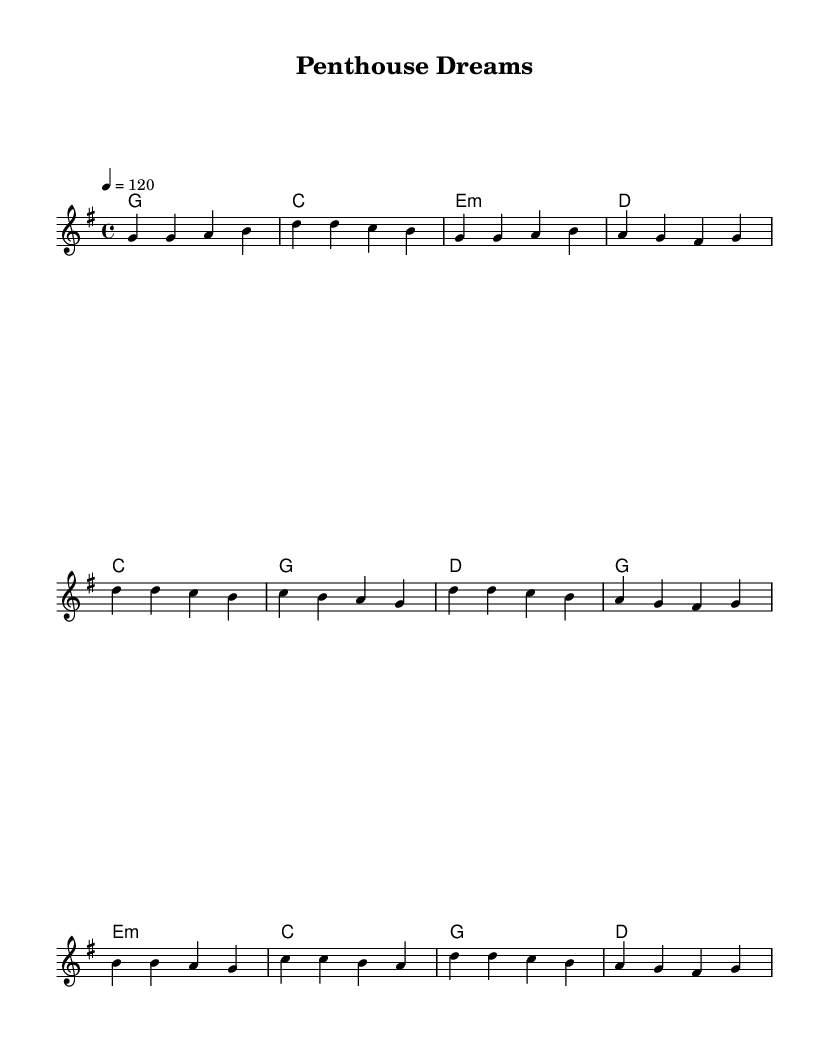What is the key signature of this music? The key signature is G major, indicated by one sharp (F#) in the sheet music.
Answer: G major What is the time signature of this piece? The time signature is 4/4, which is typical for Country Rock, allowing for a steady rhythm that supports the lyrical flow.
Answer: 4/4 What is the tempo marking for this piece? The tempo is marked as 120 beats per minute, which is a moderate pace suitable for the genre.
Answer: 120 How many verses are included in the lyrics? There are three parts in the lyrics: one verse, one chorus, and one bridge, which structure the overall composition typical for this musical style.
Answer: One What is the primary theme of the song? The primary theme is ambition, determination, and success, as reflected in the lyrics that speak of climbing to the top and achieving dreams.
Answer: Ambition How does the bridge of the song contribute to its overall message? The bridge provides a reflective element, emphasizing the luxury and heights achieved, reinforcing the theme of aspiration that runs throughout the track.
Answer: Reflective element What structure does this piece follow? The song follows a verse-chorus-bridge format, common in Country Rock, allowing for a narrative progression.
Answer: Verse-chorus-bridge 